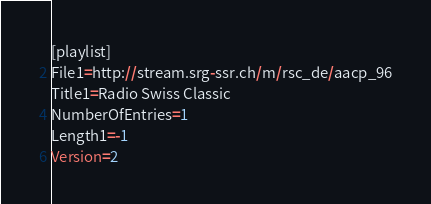Convert code to text. <code><loc_0><loc_0><loc_500><loc_500><_SQL_>[playlist]
File1=http://stream.srg-ssr.ch/m/rsc_de/aacp_96
Title1=Radio Swiss Classic
NumberOfEntries=1
Length1=-1
Version=2
</code> 